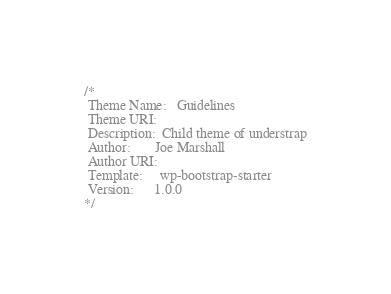Convert code to text. <code><loc_0><loc_0><loc_500><loc_500><_CSS_>/*
 Theme Name:   Guidelines
 Theme URI:    
 Description:  Child theme of understrap
 Author:       Joe Marshall
 Author URI:   
 Template:     wp-bootstrap-starter
 Version:      1.0.0
*/</code> 